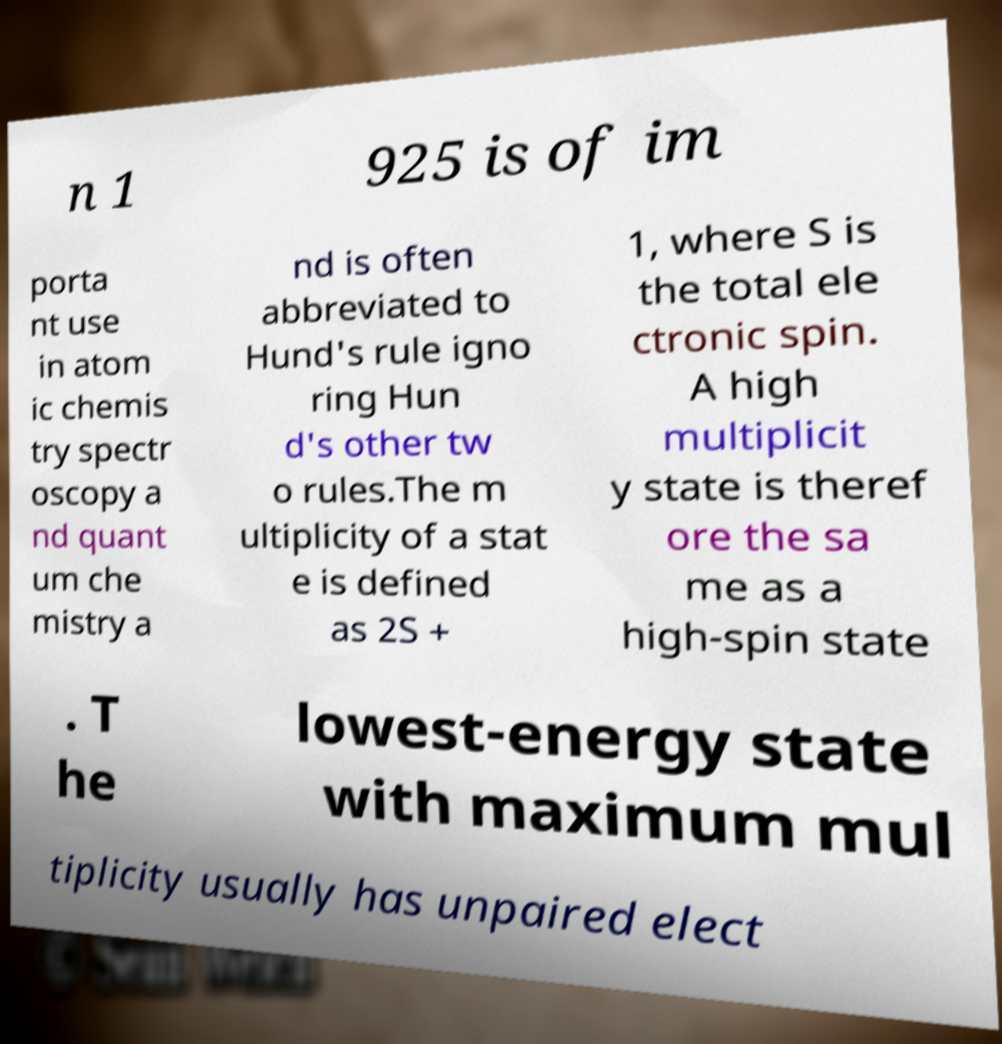What messages or text are displayed in this image? I need them in a readable, typed format. n 1 925 is of im porta nt use in atom ic chemis try spectr oscopy a nd quant um che mistry a nd is often abbreviated to Hund's rule igno ring Hun d's other tw o rules.The m ultiplicity of a stat e is defined as 2S + 1, where S is the total ele ctronic spin. A high multiplicit y state is theref ore the sa me as a high-spin state . T he lowest-energy state with maximum mul tiplicity usually has unpaired elect 